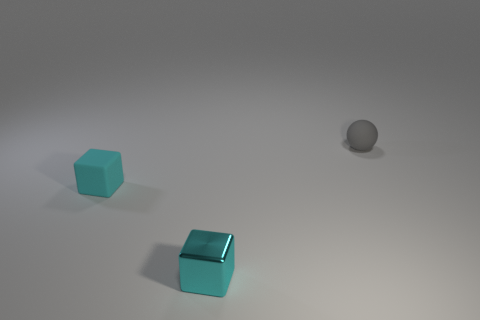Add 3 tiny gray balls. How many objects exist? 6 Subtract all balls. How many objects are left? 2 Subtract all gray balls. Subtract all cyan metallic objects. How many objects are left? 1 Add 2 cyan rubber things. How many cyan rubber things are left? 3 Add 3 small rubber cubes. How many small rubber cubes exist? 4 Subtract 0 green cylinders. How many objects are left? 3 Subtract all purple balls. Subtract all cyan cubes. How many balls are left? 1 